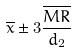<formula> <loc_0><loc_0><loc_500><loc_500>\overline { x } \pm 3 \frac { \overline { M R } } { d _ { 2 } }</formula> 